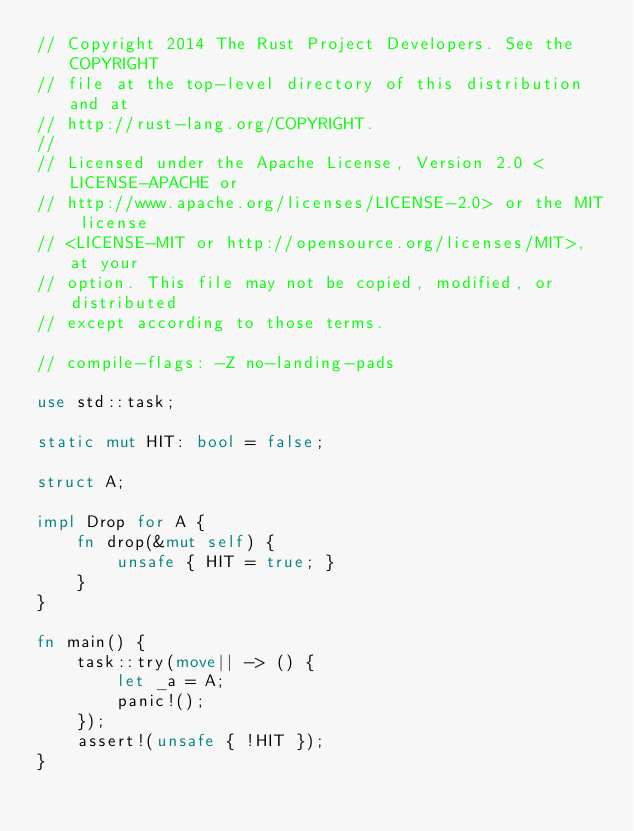<code> <loc_0><loc_0><loc_500><loc_500><_Rust_>// Copyright 2014 The Rust Project Developers. See the COPYRIGHT
// file at the top-level directory of this distribution and at
// http://rust-lang.org/COPYRIGHT.
//
// Licensed under the Apache License, Version 2.0 <LICENSE-APACHE or
// http://www.apache.org/licenses/LICENSE-2.0> or the MIT license
// <LICENSE-MIT or http://opensource.org/licenses/MIT>, at your
// option. This file may not be copied, modified, or distributed
// except according to those terms.

// compile-flags: -Z no-landing-pads

use std::task;

static mut HIT: bool = false;

struct A;

impl Drop for A {
    fn drop(&mut self) {
        unsafe { HIT = true; }
    }
}

fn main() {
    task::try(move|| -> () {
        let _a = A;
        panic!();
    });
    assert!(unsafe { !HIT });
}
</code> 